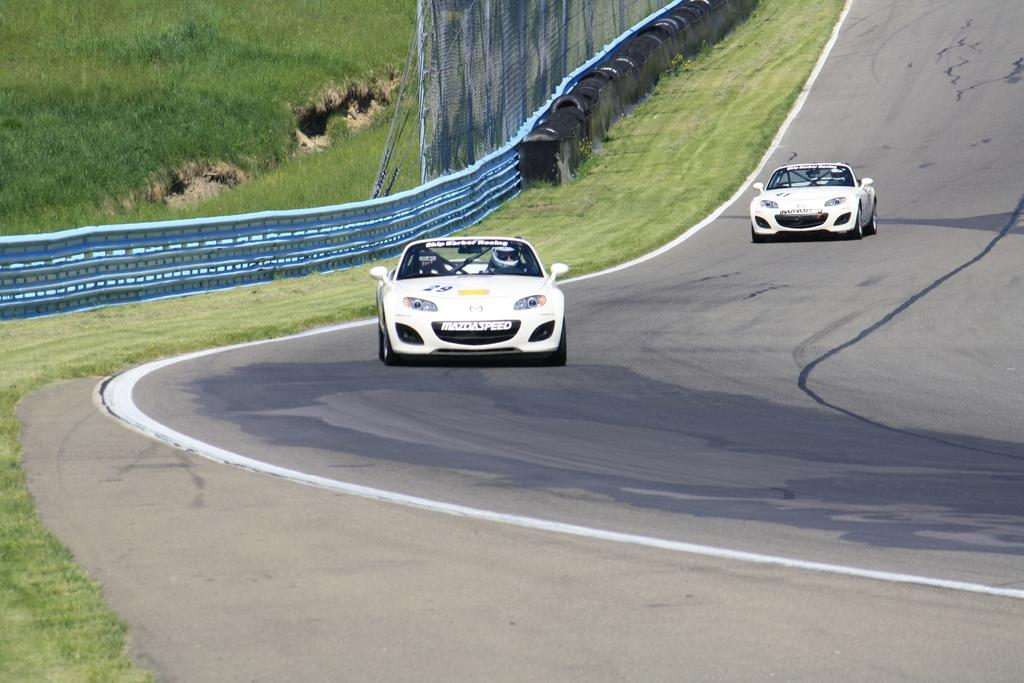What are the people in the image doing? The people in the image are riding cars on the road. What type of vegetation can be seen in the image? There is grass visible in the image. What is the purpose of the railing in the image? The railing in the image is likely used for safety or to separate different areas. Can you describe the planter in the image? The planter in the image is a container for holding plants or flowers. What color are the black objects in the image? The black objects in the image are black, but their specific purpose or identity cannot be determined from the provided facts. What is the mesh used for in the image? The mesh in the image could be used for various purposes, such as fencing, screening, or decoration. What are the ropes used for in the image? The ropes in the image could be used for various purposes, such as tying, securing, or decorating. What is the hope that the people in the image are clinging to? There is no indication in the image that the people are clinging to any hope or emotion. What type of wrench is being used to fix the car in the image? There is no wrench present in the image; the people are riding cars, not fixing them. 